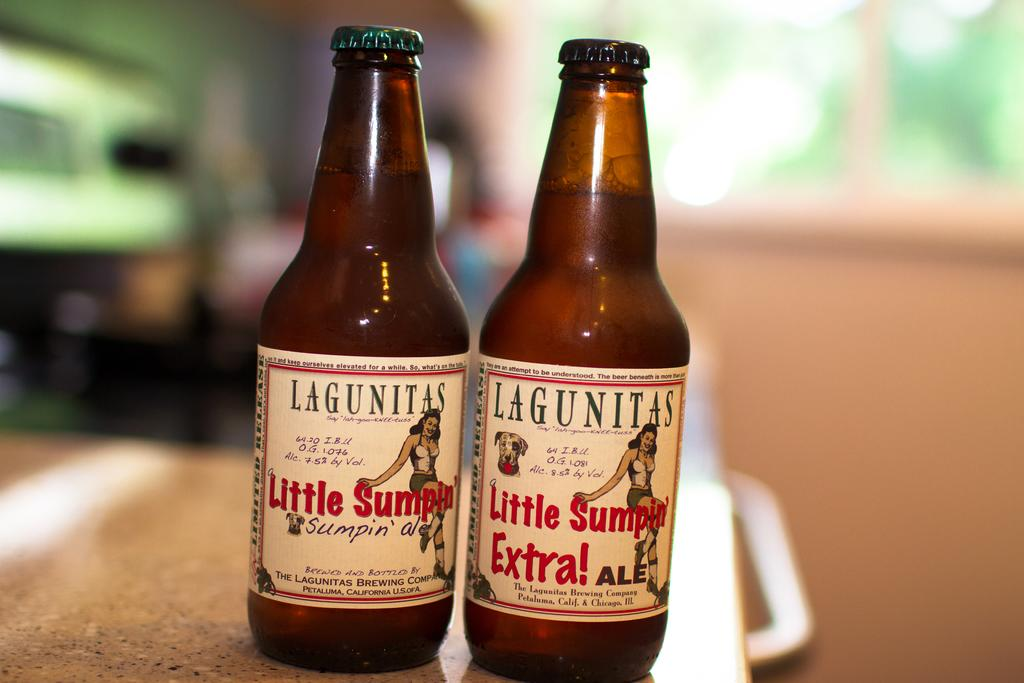How many bottles are on the table in the image? There are two bottles on the table in the image. What is unique about the bottles? White color stickers are attached to the bottles. What can be found on the stickers? There is text on the stickers. Can you describe the background of the image? The background is blurred. How many brothers are depicted in the image? There are no brothers present in the image; it features two bottles with stickers. What type of flower is growing next to the bottles in the image? There is no flower present in the image; it only shows two bottles with stickers on a table. 